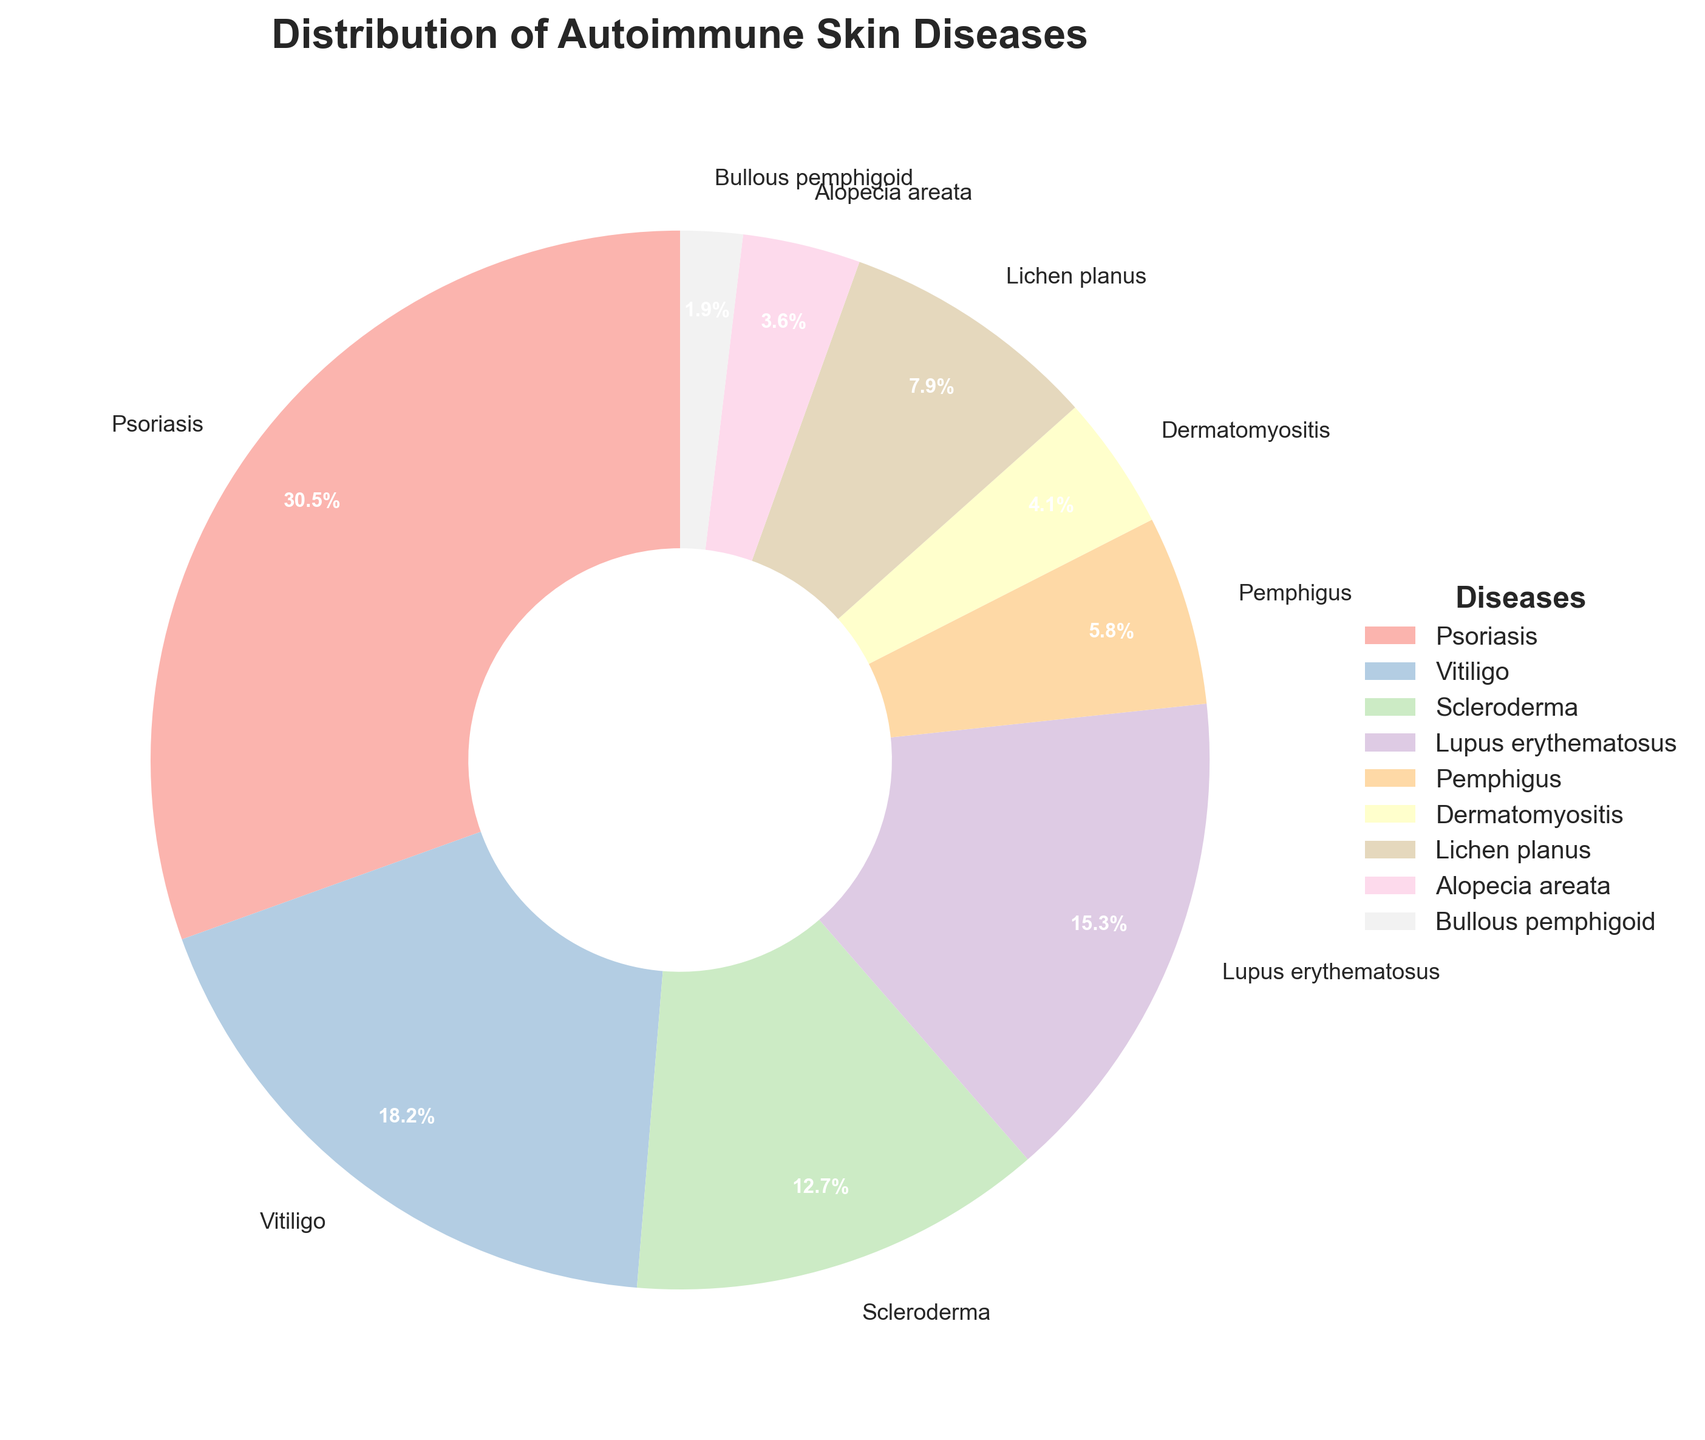What's the most common autoimmune skin disease shown in the figure? The most common autoimmune skin disease is represented by the largest wedge in the pie chart. This is indicated by the size of the slices and the percentage labels. In this case, the disease with the largest percentage is Psoriasis with 30.5%.
Answer: Psoriasis Which autoimmune skin diseases constitute more than 15% of the distribution? To determine which diseases make up more than 15% of the distribution, we need to look at the wedge labels that indicate the percentage of each disease. The diseases that have percentages greater than 15% are Psoriasis (30.5%), Vitiligo (18.2%), and Lupus erythematosus (15.3%).
Answer: Psoriasis, Vitiligo, Lupus erythematosus How does the percentage of Psoriasis compare to the percentage of Vitiligo? To compare the percentages, we look at the labels for Psoriasis and Vitiligo. Psoriasis has a percentage of 30.5%, while Vitiligo has a percentage of 18.2%. Psoriasis has a higher percentage than Vitiligo.
Answer: Psoriasis has a higher percentage than Vitiligo Which autoimmune skin diseases have a percentage less than 10%? To find the diseases with percentages less than 10%, we look at the labels for each wedge in the pie chart. The diseases with percentages less than 10% are Pemphigus (5.8%), Dermatomyositis (4.1%), Lichen planus (7.9%), Alopecia areata (3.6%), and Bullous pemphigoid (1.9%).
Answer: Pemphigus, Dermatomyositis, Lichen planus, Alopecia areata, Bullous pemphigoid What is the combined percentage of Pemphigus, Dermatomyositis, and Lichen planus? To find the combined percentage, we add the individual percentages of Pemphigus (5.8%), Dermatomyositis (4.1%), and Lichen planus (7.9%). By summing these values, we get 5.8 + 4.1 + 7.9 = 17.8%.
Answer: 17.8% Which two diseases have the closest percentages? To find which diseases have the closest percentages, we compare the percentage values of each disease. By examining the wedges' labels, we find that Dermatomyositis (4.1%) and Alopecia areata (3.6%) have the closest percentages as the difference between them is only 0.5%.
Answer: Dermatomyositis and Alopecia areata Which disease is represented by the smallest wedge in the pie chart? The smallest wedge in the pie chart corresponds to the disease with the lowest percentage. By checking all the percentage labels, we identify Bullous pemphigoid with 1.9% as the smallest wedge.
Answer: Bullous pemphigoid What visual elements are used to highlight the central part of the pie chart? The central part of the pie chart is highlighted by adding a white center circle. This design choice makes the pie chart appear as a doughnut chart, drawing attention to the distribution of wedges around the center.
Answer: White center circle 